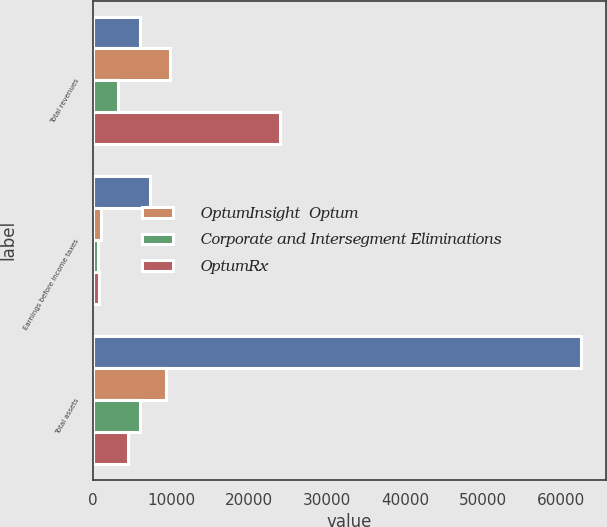Convert chart. <chart><loc_0><loc_0><loc_500><loc_500><stacked_bar_chart><ecel><fcel>Total revenues<fcel>Earnings before income taxes<fcel>Total assets<nl><fcel>nan<fcel>5971<fcel>7309<fcel>62545<nl><fcel>OptumInsight  Optum<fcel>9855<fcel>976<fcel>9329<nl><fcel>Corporate and Intersegment Eliminations<fcel>3174<fcel>603<fcel>5971<nl><fcel>OptumRx<fcel>24006<fcel>735<fcel>4525<nl></chart> 